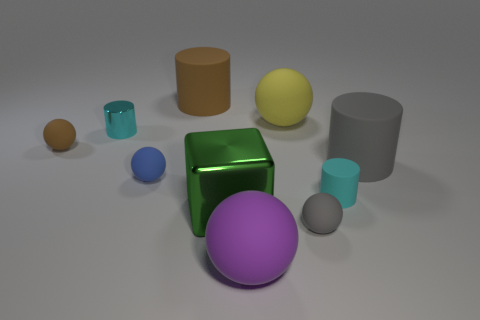Subtract all purple spheres. How many spheres are left? 4 Subtract all blue matte spheres. How many spheres are left? 4 Subtract 1 cylinders. How many cylinders are left? 3 Subtract all cyan balls. Subtract all yellow cubes. How many balls are left? 5 Subtract all cylinders. How many objects are left? 6 Add 5 tiny cyan rubber objects. How many tiny cyan rubber objects exist? 6 Subtract 1 blue balls. How many objects are left? 9 Subtract all large green rubber balls. Subtract all large yellow matte balls. How many objects are left? 9 Add 3 gray spheres. How many gray spheres are left? 4 